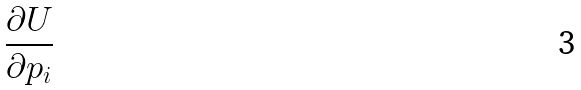Convert formula to latex. <formula><loc_0><loc_0><loc_500><loc_500>\frac { \partial U } { \partial p _ { i } }</formula> 